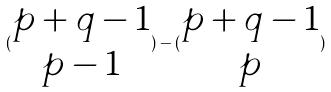Convert formula to latex. <formula><loc_0><loc_0><loc_500><loc_500>( \begin{matrix} p + q - 1 \\ p - 1 \end{matrix} ) - ( \begin{matrix} p + q - 1 \\ p \end{matrix} )</formula> 